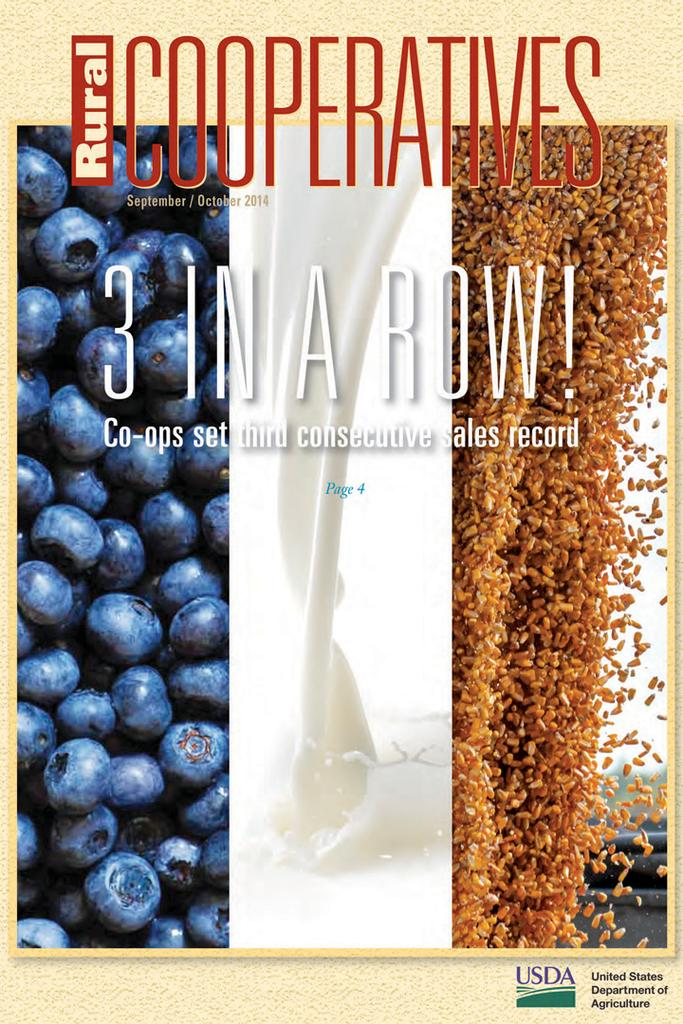Provide a one-sentence caption for the provided image. Rural Cooperatives' September/October 2014 issue featured co-ops setting third consecutive sales record. 